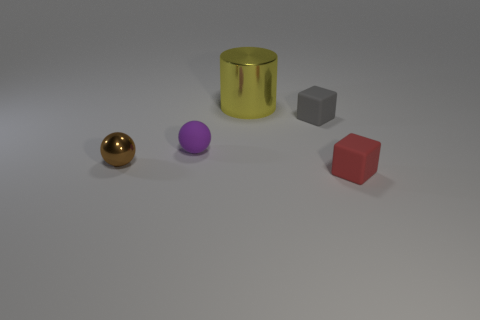Subtract all spheres. How many objects are left? 3 Add 1 small gray rubber objects. How many objects exist? 6 Subtract all brown spheres. How many purple blocks are left? 0 Subtract all tiny purple things. Subtract all tiny gray things. How many objects are left? 3 Add 4 tiny brown metal objects. How many tiny brown metal objects are left? 5 Add 5 large metallic things. How many large metallic things exist? 6 Subtract 1 brown balls. How many objects are left? 4 Subtract 2 spheres. How many spheres are left? 0 Subtract all cyan blocks. Subtract all blue cylinders. How many blocks are left? 2 